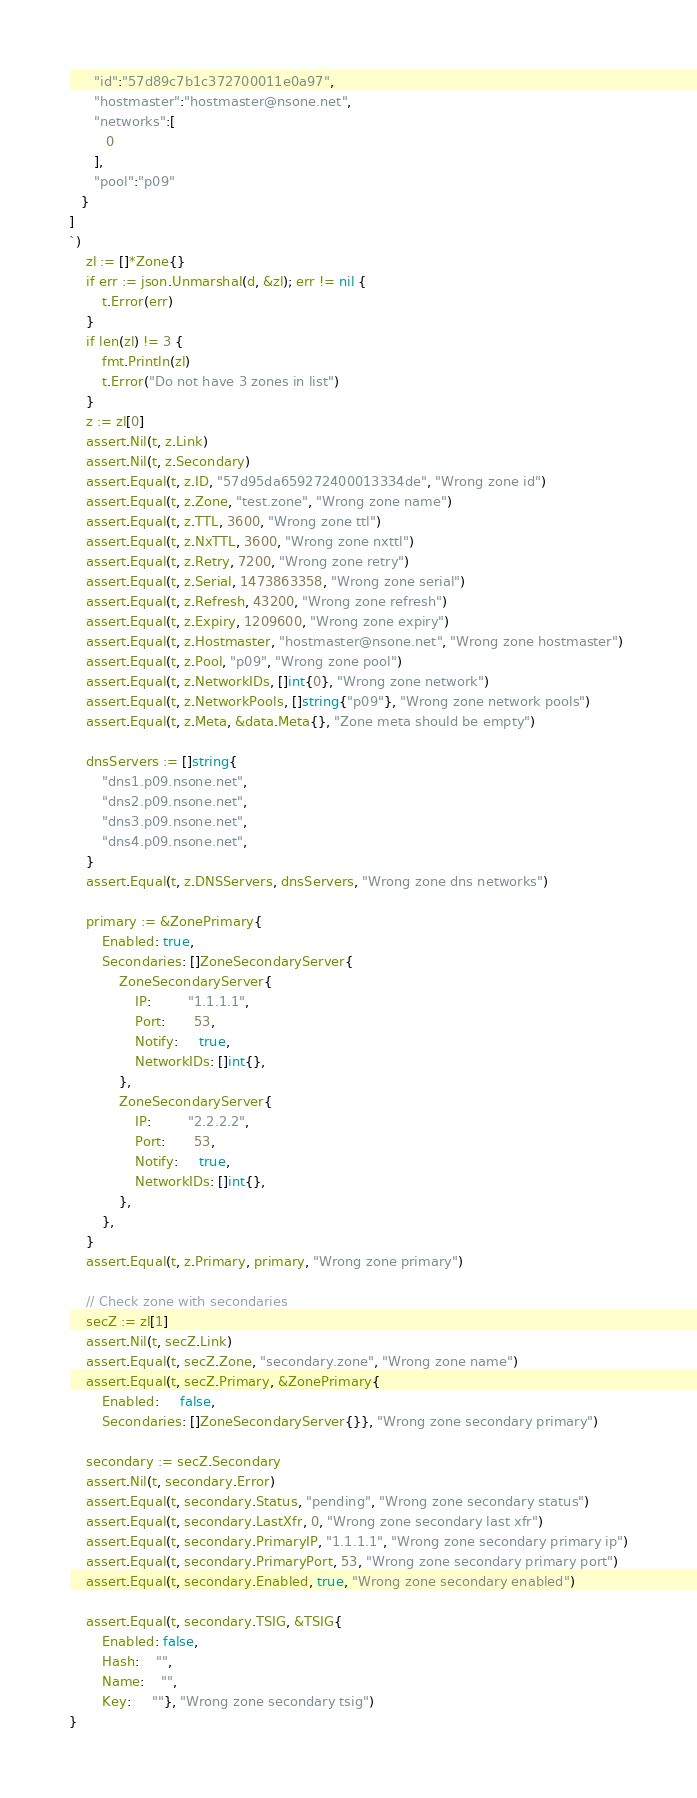Convert code to text. <code><loc_0><loc_0><loc_500><loc_500><_Go_>      "id":"57d89c7b1c372700011e0a97",
      "hostmaster":"hostmaster@nsone.net",
      "networks":[  
         0
      ],
      "pool":"p09"
   }
]
`)
	zl := []*Zone{}
	if err := json.Unmarshal(d, &zl); err != nil {
		t.Error(err)
	}
	if len(zl) != 3 {
		fmt.Println(zl)
		t.Error("Do not have 3 zones in list")
	}
	z := zl[0]
	assert.Nil(t, z.Link)
	assert.Nil(t, z.Secondary)
	assert.Equal(t, z.ID, "57d95da659272400013334de", "Wrong zone id")
	assert.Equal(t, z.Zone, "test.zone", "Wrong zone name")
	assert.Equal(t, z.TTL, 3600, "Wrong zone ttl")
	assert.Equal(t, z.NxTTL, 3600, "Wrong zone nxttl")
	assert.Equal(t, z.Retry, 7200, "Wrong zone retry")
	assert.Equal(t, z.Serial, 1473863358, "Wrong zone serial")
	assert.Equal(t, z.Refresh, 43200, "Wrong zone refresh")
	assert.Equal(t, z.Expiry, 1209600, "Wrong zone expiry")
	assert.Equal(t, z.Hostmaster, "hostmaster@nsone.net", "Wrong zone hostmaster")
	assert.Equal(t, z.Pool, "p09", "Wrong zone pool")
	assert.Equal(t, z.NetworkIDs, []int{0}, "Wrong zone network")
	assert.Equal(t, z.NetworkPools, []string{"p09"}, "Wrong zone network pools")
	assert.Equal(t, z.Meta, &data.Meta{}, "Zone meta should be empty")

	dnsServers := []string{
		"dns1.p09.nsone.net",
		"dns2.p09.nsone.net",
		"dns3.p09.nsone.net",
		"dns4.p09.nsone.net",
	}
	assert.Equal(t, z.DNSServers, dnsServers, "Wrong zone dns networks")

	primary := &ZonePrimary{
		Enabled: true,
		Secondaries: []ZoneSecondaryServer{
			ZoneSecondaryServer{
				IP:         "1.1.1.1",
				Port:       53,
				Notify:     true,
				NetworkIDs: []int{},
			},
			ZoneSecondaryServer{
				IP:         "2.2.2.2",
				Port:       53,
				Notify:     true,
				NetworkIDs: []int{},
			},
		},
	}
	assert.Equal(t, z.Primary, primary, "Wrong zone primary")

	// Check zone with secondaries
	secZ := zl[1]
	assert.Nil(t, secZ.Link)
	assert.Equal(t, secZ.Zone, "secondary.zone", "Wrong zone name")
	assert.Equal(t, secZ.Primary, &ZonePrimary{
		Enabled:     false,
		Secondaries: []ZoneSecondaryServer{}}, "Wrong zone secondary primary")

	secondary := secZ.Secondary
	assert.Nil(t, secondary.Error)
	assert.Equal(t, secondary.Status, "pending", "Wrong zone secondary status")
	assert.Equal(t, secondary.LastXfr, 0, "Wrong zone secondary last xfr")
	assert.Equal(t, secondary.PrimaryIP, "1.1.1.1", "Wrong zone secondary primary ip")
	assert.Equal(t, secondary.PrimaryPort, 53, "Wrong zone secondary primary port")
	assert.Equal(t, secondary.Enabled, true, "Wrong zone secondary enabled")

	assert.Equal(t, secondary.TSIG, &TSIG{
		Enabled: false,
		Hash:    "",
		Name:    "",
		Key:     ""}, "Wrong zone secondary tsig")
}
</code> 